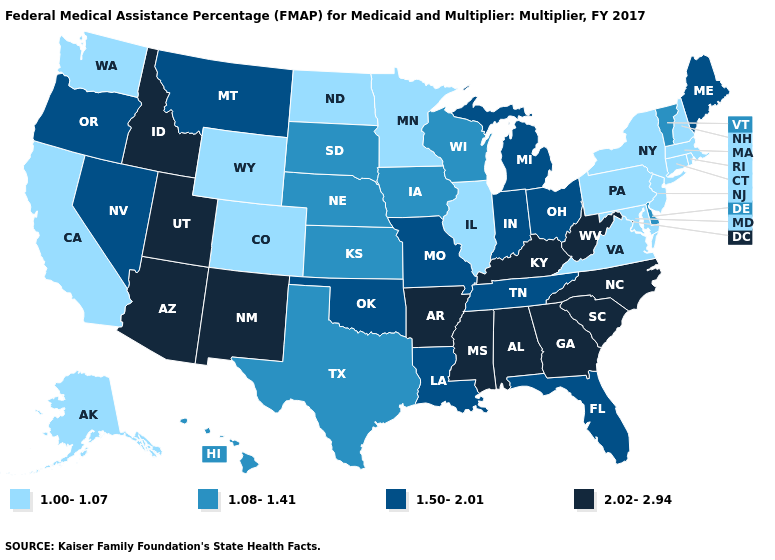Name the states that have a value in the range 2.02-2.94?
Short answer required. Alabama, Arizona, Arkansas, Georgia, Idaho, Kentucky, Mississippi, New Mexico, North Carolina, South Carolina, Utah, West Virginia. Does the map have missing data?
Short answer required. No. What is the value of West Virginia?
Answer briefly. 2.02-2.94. Does Maine have the lowest value in the USA?
Keep it brief. No. Which states have the lowest value in the West?
Write a very short answer. Alaska, California, Colorado, Washington, Wyoming. Among the states that border Kansas , which have the lowest value?
Keep it brief. Colorado. What is the highest value in states that border Alabama?
Give a very brief answer. 2.02-2.94. Does Maine have the highest value in the USA?
Answer briefly. No. Name the states that have a value in the range 1.50-2.01?
Give a very brief answer. Florida, Indiana, Louisiana, Maine, Michigan, Missouri, Montana, Nevada, Ohio, Oklahoma, Oregon, Tennessee. Name the states that have a value in the range 1.08-1.41?
Write a very short answer. Delaware, Hawaii, Iowa, Kansas, Nebraska, South Dakota, Texas, Vermont, Wisconsin. Does Florida have the lowest value in the USA?
Keep it brief. No. Does West Virginia have the highest value in the USA?
Be succinct. Yes. Name the states that have a value in the range 2.02-2.94?
Answer briefly. Alabama, Arizona, Arkansas, Georgia, Idaho, Kentucky, Mississippi, New Mexico, North Carolina, South Carolina, Utah, West Virginia. Is the legend a continuous bar?
Concise answer only. No. Name the states that have a value in the range 2.02-2.94?
Short answer required. Alabama, Arizona, Arkansas, Georgia, Idaho, Kentucky, Mississippi, New Mexico, North Carolina, South Carolina, Utah, West Virginia. 